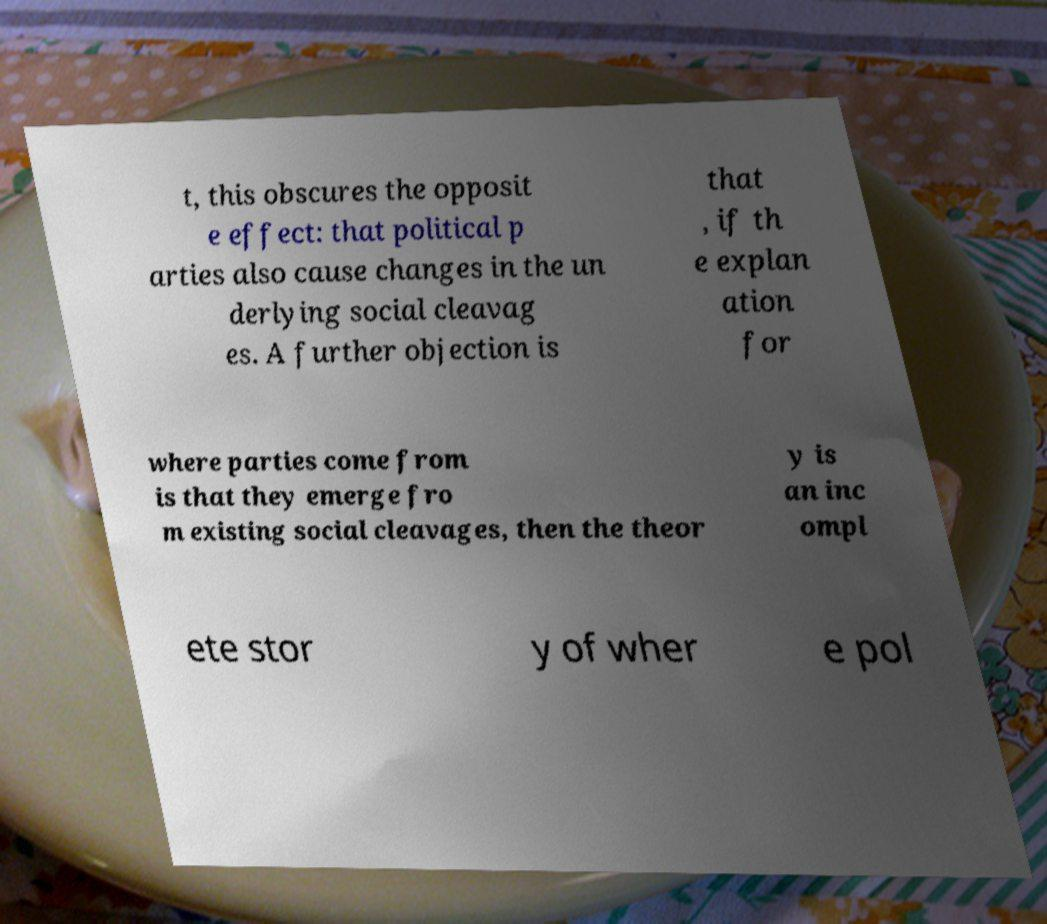For documentation purposes, I need the text within this image transcribed. Could you provide that? t, this obscures the opposit e effect: that political p arties also cause changes in the un derlying social cleavag es. A further objection is that , if th e explan ation for where parties come from is that they emerge fro m existing social cleavages, then the theor y is an inc ompl ete stor y of wher e pol 